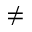<formula> <loc_0><loc_0><loc_500><loc_500>\neq</formula> 